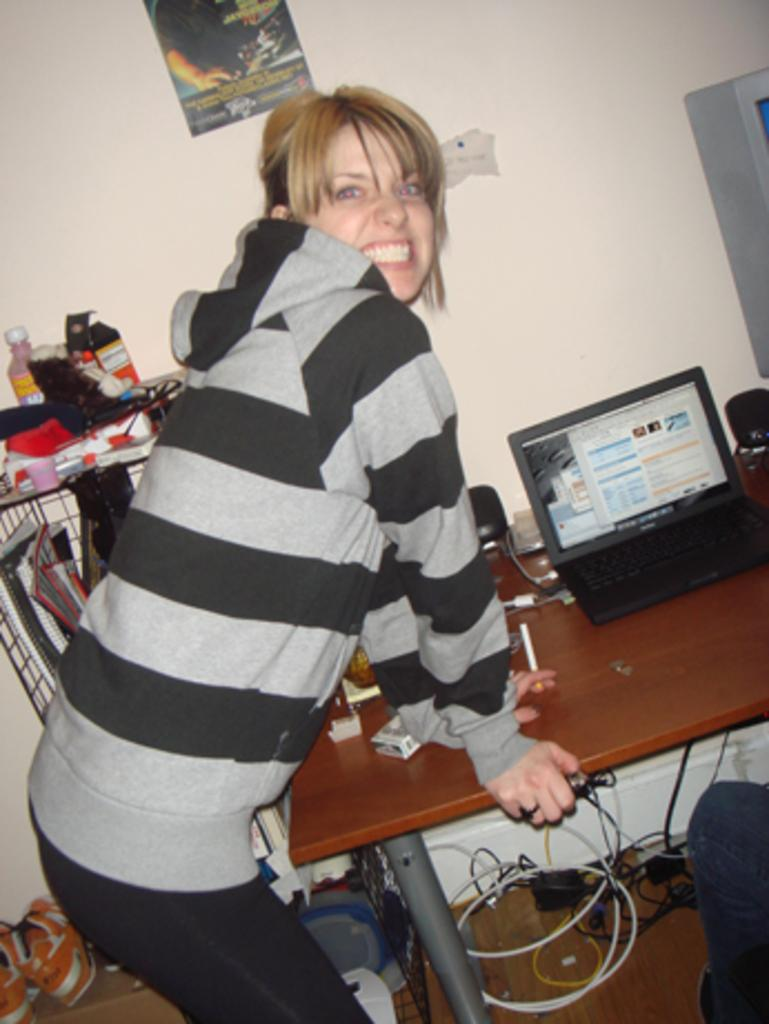Who is present in the image? There is a woman in the image. What is the woman doing in the image? The woman is standing and holding a table with her hand. What object is on the table the woman is holding? There is a laptop on the table. What can be seen on the wall in the image? There is a poster on the wall. How does the woman wash the mountain in the image? There is no mountain present in the image, and the woman is not washing anything. 